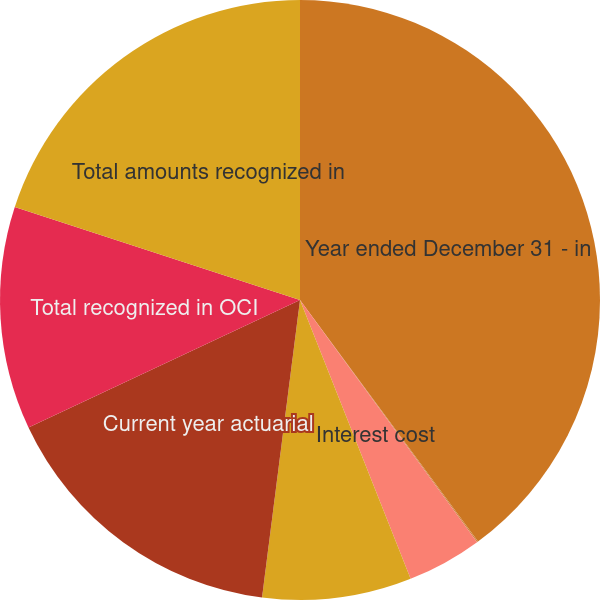<chart> <loc_0><loc_0><loc_500><loc_500><pie_chart><fcel>Year ended December 31 - in<fcel>Service cost<fcel>Interest cost<fcel>Net periodic cost (benefit)<fcel>Current year actuarial<fcel>Total recognized in OCI<fcel>Total amounts recognized in<nl><fcel>39.89%<fcel>0.06%<fcel>4.04%<fcel>8.03%<fcel>15.99%<fcel>12.01%<fcel>19.98%<nl></chart> 